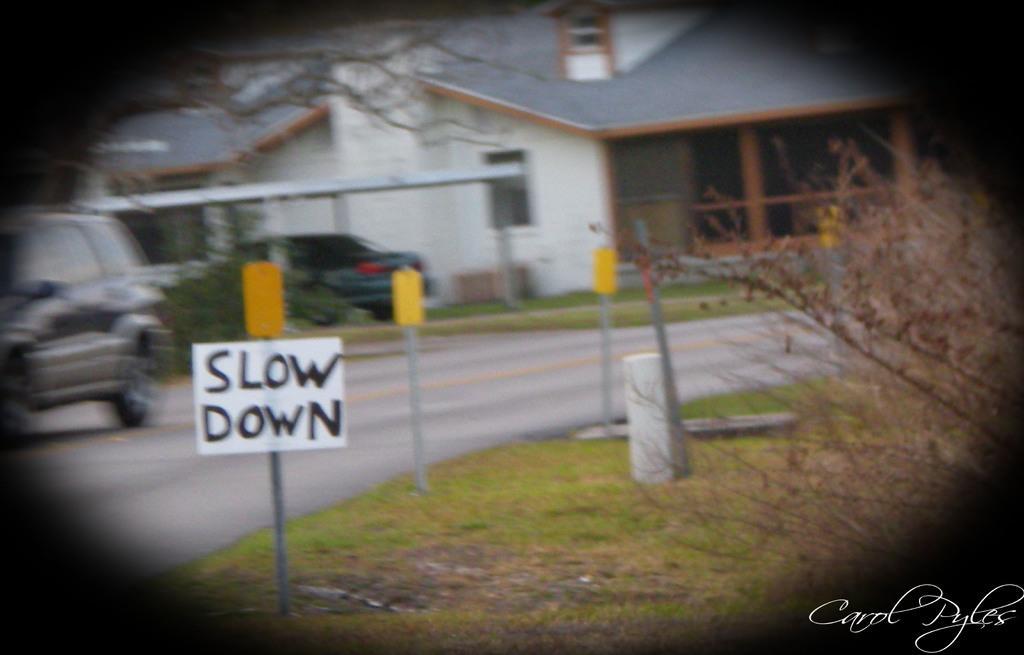Can you describe this image briefly? In this image we can see board, vehicles, road, poles, plants, grass, trees and houses. 